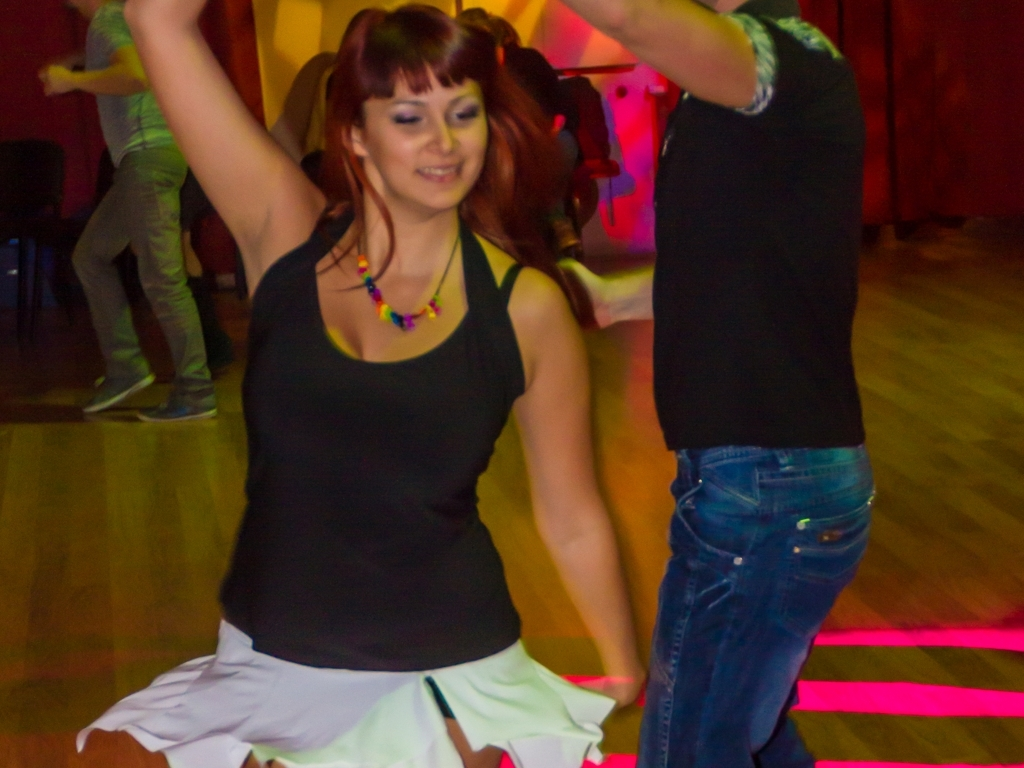What are the people in this image doing? The individuals in this image appear to be dancing, likely enjoying a lively social event or class. Their poses and smiles suggest a fun, high-energy atmosphere. 